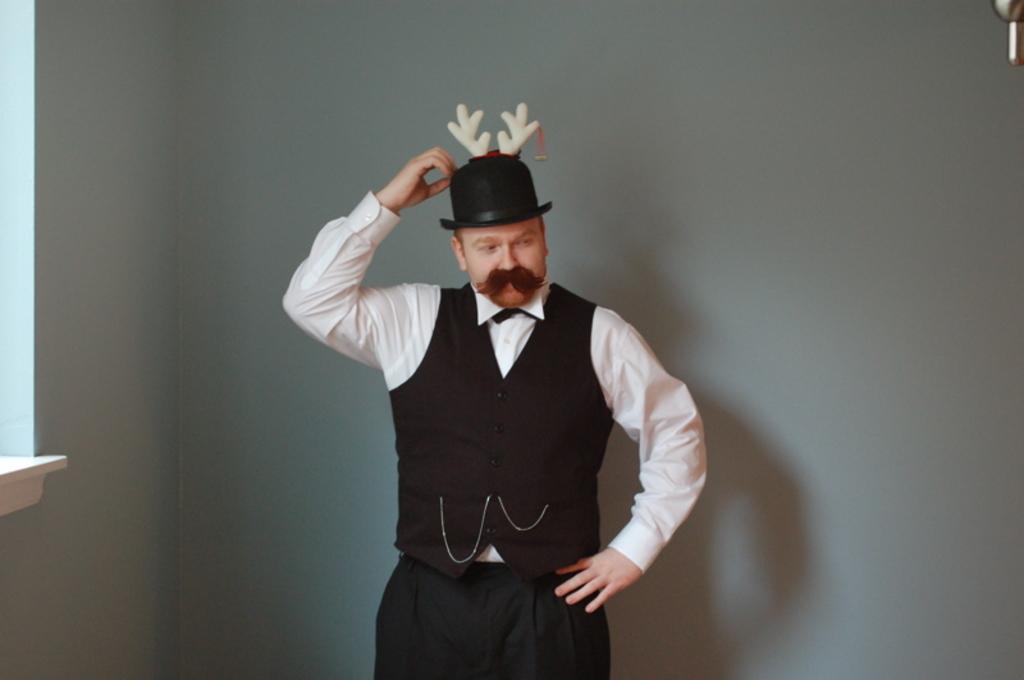Please provide a concise description of this image. The man in the middle of the picture wearing a white shirt and black coat is standing. He is wearing a black hat. Behind him, we see a wall in white color. 